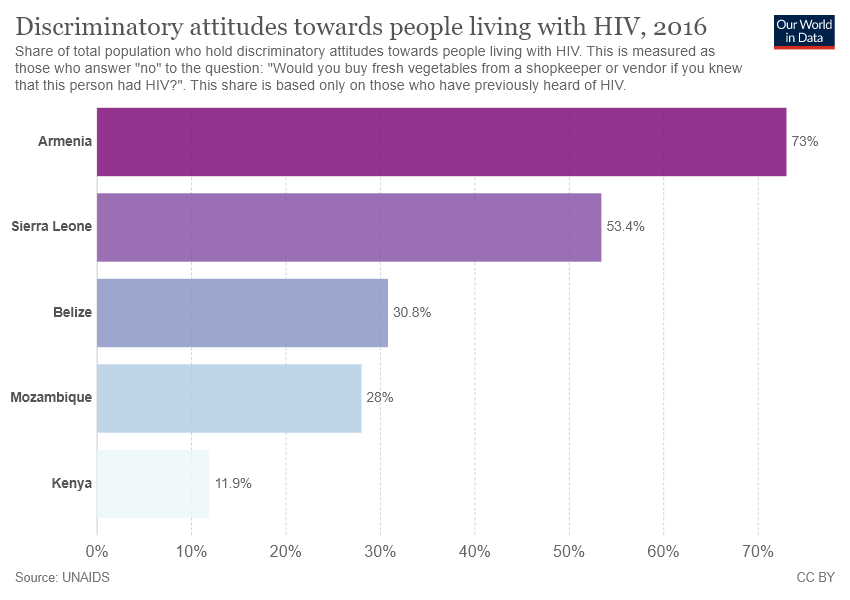Indicate a few pertinent items in this graphic. The smallest bar has a value of approximately 0.119... 